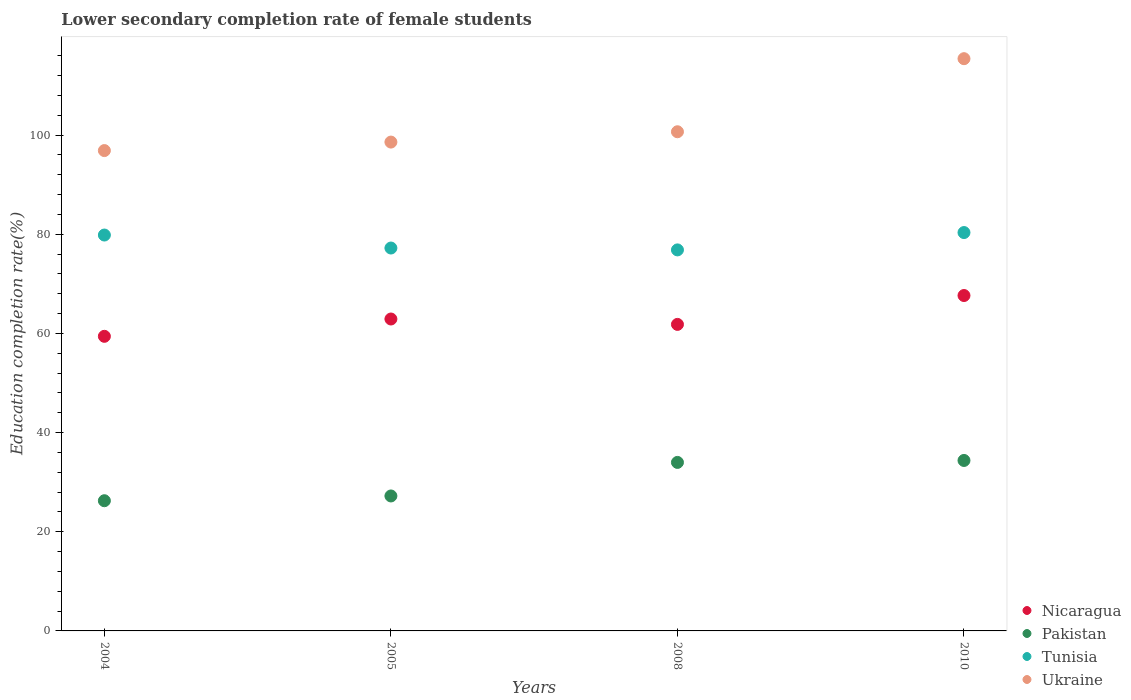How many different coloured dotlines are there?
Make the answer very short. 4. Is the number of dotlines equal to the number of legend labels?
Make the answer very short. Yes. What is the lower secondary completion rate of female students in Nicaragua in 2010?
Your answer should be very brief. 67.65. Across all years, what is the maximum lower secondary completion rate of female students in Pakistan?
Ensure brevity in your answer.  34.38. Across all years, what is the minimum lower secondary completion rate of female students in Pakistan?
Make the answer very short. 26.26. In which year was the lower secondary completion rate of female students in Pakistan maximum?
Provide a short and direct response. 2010. In which year was the lower secondary completion rate of female students in Pakistan minimum?
Make the answer very short. 2004. What is the total lower secondary completion rate of female students in Ukraine in the graph?
Provide a succinct answer. 411.59. What is the difference between the lower secondary completion rate of female students in Tunisia in 2005 and that in 2008?
Offer a very short reply. 0.38. What is the difference between the lower secondary completion rate of female students in Pakistan in 2008 and the lower secondary completion rate of female students in Nicaragua in 2010?
Keep it short and to the point. -33.66. What is the average lower secondary completion rate of female students in Nicaragua per year?
Ensure brevity in your answer.  62.95. In the year 2008, what is the difference between the lower secondary completion rate of female students in Pakistan and lower secondary completion rate of female students in Nicaragua?
Your answer should be very brief. -27.84. In how many years, is the lower secondary completion rate of female students in Pakistan greater than 96 %?
Provide a succinct answer. 0. What is the ratio of the lower secondary completion rate of female students in Ukraine in 2004 to that in 2005?
Your response must be concise. 0.98. Is the lower secondary completion rate of female students in Nicaragua in 2004 less than that in 2005?
Make the answer very short. Yes. Is the difference between the lower secondary completion rate of female students in Pakistan in 2004 and 2008 greater than the difference between the lower secondary completion rate of female students in Nicaragua in 2004 and 2008?
Keep it short and to the point. No. What is the difference between the highest and the second highest lower secondary completion rate of female students in Nicaragua?
Provide a short and direct response. 4.74. What is the difference between the highest and the lowest lower secondary completion rate of female students in Nicaragua?
Keep it short and to the point. 8.23. In how many years, is the lower secondary completion rate of female students in Nicaragua greater than the average lower secondary completion rate of female students in Nicaragua taken over all years?
Your answer should be compact. 1. Does the lower secondary completion rate of female students in Nicaragua monotonically increase over the years?
Keep it short and to the point. No. Is the lower secondary completion rate of female students in Pakistan strictly less than the lower secondary completion rate of female students in Tunisia over the years?
Make the answer very short. Yes. How many dotlines are there?
Give a very brief answer. 4. Are the values on the major ticks of Y-axis written in scientific E-notation?
Provide a short and direct response. No. Does the graph contain grids?
Give a very brief answer. No. How many legend labels are there?
Offer a terse response. 4. What is the title of the graph?
Offer a very short reply. Lower secondary completion rate of female students. Does "Least developed countries" appear as one of the legend labels in the graph?
Give a very brief answer. No. What is the label or title of the X-axis?
Your response must be concise. Years. What is the label or title of the Y-axis?
Provide a succinct answer. Education completion rate(%). What is the Education completion rate(%) of Nicaragua in 2004?
Give a very brief answer. 59.42. What is the Education completion rate(%) in Pakistan in 2004?
Your answer should be compact. 26.26. What is the Education completion rate(%) in Tunisia in 2004?
Offer a terse response. 79.85. What is the Education completion rate(%) in Ukraine in 2004?
Your answer should be compact. 96.89. What is the Education completion rate(%) in Nicaragua in 2005?
Your answer should be very brief. 62.91. What is the Education completion rate(%) in Pakistan in 2005?
Your response must be concise. 27.22. What is the Education completion rate(%) of Tunisia in 2005?
Your response must be concise. 77.23. What is the Education completion rate(%) of Ukraine in 2005?
Keep it short and to the point. 98.6. What is the Education completion rate(%) in Nicaragua in 2008?
Give a very brief answer. 61.83. What is the Education completion rate(%) in Pakistan in 2008?
Keep it short and to the point. 33.99. What is the Education completion rate(%) in Tunisia in 2008?
Your response must be concise. 76.85. What is the Education completion rate(%) of Ukraine in 2008?
Your response must be concise. 100.68. What is the Education completion rate(%) in Nicaragua in 2010?
Provide a short and direct response. 67.65. What is the Education completion rate(%) in Pakistan in 2010?
Offer a very short reply. 34.38. What is the Education completion rate(%) in Tunisia in 2010?
Provide a succinct answer. 80.35. What is the Education completion rate(%) in Ukraine in 2010?
Ensure brevity in your answer.  115.42. Across all years, what is the maximum Education completion rate(%) in Nicaragua?
Provide a short and direct response. 67.65. Across all years, what is the maximum Education completion rate(%) of Pakistan?
Make the answer very short. 34.38. Across all years, what is the maximum Education completion rate(%) of Tunisia?
Make the answer very short. 80.35. Across all years, what is the maximum Education completion rate(%) of Ukraine?
Offer a terse response. 115.42. Across all years, what is the minimum Education completion rate(%) in Nicaragua?
Provide a short and direct response. 59.42. Across all years, what is the minimum Education completion rate(%) in Pakistan?
Offer a very short reply. 26.26. Across all years, what is the minimum Education completion rate(%) in Tunisia?
Provide a short and direct response. 76.85. Across all years, what is the minimum Education completion rate(%) in Ukraine?
Offer a very short reply. 96.89. What is the total Education completion rate(%) of Nicaragua in the graph?
Your answer should be very brief. 251.81. What is the total Education completion rate(%) in Pakistan in the graph?
Give a very brief answer. 121.85. What is the total Education completion rate(%) in Tunisia in the graph?
Give a very brief answer. 314.28. What is the total Education completion rate(%) in Ukraine in the graph?
Offer a terse response. 411.59. What is the difference between the Education completion rate(%) of Nicaragua in 2004 and that in 2005?
Ensure brevity in your answer.  -3.49. What is the difference between the Education completion rate(%) of Pakistan in 2004 and that in 2005?
Your answer should be very brief. -0.96. What is the difference between the Education completion rate(%) in Tunisia in 2004 and that in 2005?
Give a very brief answer. 2.62. What is the difference between the Education completion rate(%) of Ukraine in 2004 and that in 2005?
Your response must be concise. -1.71. What is the difference between the Education completion rate(%) of Nicaragua in 2004 and that in 2008?
Offer a terse response. -2.41. What is the difference between the Education completion rate(%) of Pakistan in 2004 and that in 2008?
Your answer should be compact. -7.73. What is the difference between the Education completion rate(%) of Tunisia in 2004 and that in 2008?
Your response must be concise. 3. What is the difference between the Education completion rate(%) in Ukraine in 2004 and that in 2008?
Your response must be concise. -3.8. What is the difference between the Education completion rate(%) in Nicaragua in 2004 and that in 2010?
Offer a very short reply. -8.23. What is the difference between the Education completion rate(%) of Pakistan in 2004 and that in 2010?
Provide a succinct answer. -8.12. What is the difference between the Education completion rate(%) of Tunisia in 2004 and that in 2010?
Ensure brevity in your answer.  -0.5. What is the difference between the Education completion rate(%) of Ukraine in 2004 and that in 2010?
Your answer should be very brief. -18.54. What is the difference between the Education completion rate(%) in Nicaragua in 2005 and that in 2008?
Provide a short and direct response. 1.09. What is the difference between the Education completion rate(%) in Pakistan in 2005 and that in 2008?
Give a very brief answer. -6.77. What is the difference between the Education completion rate(%) of Tunisia in 2005 and that in 2008?
Your answer should be compact. 0.38. What is the difference between the Education completion rate(%) of Ukraine in 2005 and that in 2008?
Provide a short and direct response. -2.08. What is the difference between the Education completion rate(%) of Nicaragua in 2005 and that in 2010?
Keep it short and to the point. -4.74. What is the difference between the Education completion rate(%) in Pakistan in 2005 and that in 2010?
Make the answer very short. -7.16. What is the difference between the Education completion rate(%) of Tunisia in 2005 and that in 2010?
Provide a short and direct response. -3.12. What is the difference between the Education completion rate(%) of Ukraine in 2005 and that in 2010?
Make the answer very short. -16.82. What is the difference between the Education completion rate(%) in Nicaragua in 2008 and that in 2010?
Provide a succinct answer. -5.82. What is the difference between the Education completion rate(%) of Pakistan in 2008 and that in 2010?
Keep it short and to the point. -0.39. What is the difference between the Education completion rate(%) in Tunisia in 2008 and that in 2010?
Ensure brevity in your answer.  -3.5. What is the difference between the Education completion rate(%) in Ukraine in 2008 and that in 2010?
Provide a short and direct response. -14.74. What is the difference between the Education completion rate(%) of Nicaragua in 2004 and the Education completion rate(%) of Pakistan in 2005?
Provide a short and direct response. 32.2. What is the difference between the Education completion rate(%) of Nicaragua in 2004 and the Education completion rate(%) of Tunisia in 2005?
Ensure brevity in your answer.  -17.81. What is the difference between the Education completion rate(%) in Nicaragua in 2004 and the Education completion rate(%) in Ukraine in 2005?
Offer a very short reply. -39.18. What is the difference between the Education completion rate(%) of Pakistan in 2004 and the Education completion rate(%) of Tunisia in 2005?
Provide a short and direct response. -50.97. What is the difference between the Education completion rate(%) of Pakistan in 2004 and the Education completion rate(%) of Ukraine in 2005?
Offer a terse response. -72.34. What is the difference between the Education completion rate(%) of Tunisia in 2004 and the Education completion rate(%) of Ukraine in 2005?
Offer a terse response. -18.75. What is the difference between the Education completion rate(%) of Nicaragua in 2004 and the Education completion rate(%) of Pakistan in 2008?
Provide a succinct answer. 25.43. What is the difference between the Education completion rate(%) in Nicaragua in 2004 and the Education completion rate(%) in Tunisia in 2008?
Give a very brief answer. -17.43. What is the difference between the Education completion rate(%) in Nicaragua in 2004 and the Education completion rate(%) in Ukraine in 2008?
Provide a short and direct response. -41.26. What is the difference between the Education completion rate(%) in Pakistan in 2004 and the Education completion rate(%) in Tunisia in 2008?
Your answer should be compact. -50.59. What is the difference between the Education completion rate(%) of Pakistan in 2004 and the Education completion rate(%) of Ukraine in 2008?
Offer a terse response. -74.42. What is the difference between the Education completion rate(%) in Tunisia in 2004 and the Education completion rate(%) in Ukraine in 2008?
Ensure brevity in your answer.  -20.83. What is the difference between the Education completion rate(%) of Nicaragua in 2004 and the Education completion rate(%) of Pakistan in 2010?
Keep it short and to the point. 25.04. What is the difference between the Education completion rate(%) in Nicaragua in 2004 and the Education completion rate(%) in Tunisia in 2010?
Provide a short and direct response. -20.93. What is the difference between the Education completion rate(%) in Nicaragua in 2004 and the Education completion rate(%) in Ukraine in 2010?
Your answer should be compact. -56. What is the difference between the Education completion rate(%) in Pakistan in 2004 and the Education completion rate(%) in Tunisia in 2010?
Offer a very short reply. -54.09. What is the difference between the Education completion rate(%) in Pakistan in 2004 and the Education completion rate(%) in Ukraine in 2010?
Provide a short and direct response. -89.16. What is the difference between the Education completion rate(%) of Tunisia in 2004 and the Education completion rate(%) of Ukraine in 2010?
Offer a very short reply. -35.57. What is the difference between the Education completion rate(%) of Nicaragua in 2005 and the Education completion rate(%) of Pakistan in 2008?
Make the answer very short. 28.92. What is the difference between the Education completion rate(%) of Nicaragua in 2005 and the Education completion rate(%) of Tunisia in 2008?
Offer a terse response. -13.94. What is the difference between the Education completion rate(%) in Nicaragua in 2005 and the Education completion rate(%) in Ukraine in 2008?
Provide a short and direct response. -37.77. What is the difference between the Education completion rate(%) in Pakistan in 2005 and the Education completion rate(%) in Tunisia in 2008?
Make the answer very short. -49.63. What is the difference between the Education completion rate(%) in Pakistan in 2005 and the Education completion rate(%) in Ukraine in 2008?
Offer a very short reply. -73.46. What is the difference between the Education completion rate(%) of Tunisia in 2005 and the Education completion rate(%) of Ukraine in 2008?
Keep it short and to the point. -23.45. What is the difference between the Education completion rate(%) in Nicaragua in 2005 and the Education completion rate(%) in Pakistan in 2010?
Offer a very short reply. 28.53. What is the difference between the Education completion rate(%) in Nicaragua in 2005 and the Education completion rate(%) in Tunisia in 2010?
Keep it short and to the point. -17.44. What is the difference between the Education completion rate(%) in Nicaragua in 2005 and the Education completion rate(%) in Ukraine in 2010?
Offer a very short reply. -52.51. What is the difference between the Education completion rate(%) of Pakistan in 2005 and the Education completion rate(%) of Tunisia in 2010?
Provide a short and direct response. -53.13. What is the difference between the Education completion rate(%) in Pakistan in 2005 and the Education completion rate(%) in Ukraine in 2010?
Offer a very short reply. -88.2. What is the difference between the Education completion rate(%) of Tunisia in 2005 and the Education completion rate(%) of Ukraine in 2010?
Keep it short and to the point. -38.19. What is the difference between the Education completion rate(%) in Nicaragua in 2008 and the Education completion rate(%) in Pakistan in 2010?
Make the answer very short. 27.45. What is the difference between the Education completion rate(%) of Nicaragua in 2008 and the Education completion rate(%) of Tunisia in 2010?
Make the answer very short. -18.52. What is the difference between the Education completion rate(%) in Nicaragua in 2008 and the Education completion rate(%) in Ukraine in 2010?
Your answer should be very brief. -53.59. What is the difference between the Education completion rate(%) of Pakistan in 2008 and the Education completion rate(%) of Tunisia in 2010?
Provide a short and direct response. -46.36. What is the difference between the Education completion rate(%) of Pakistan in 2008 and the Education completion rate(%) of Ukraine in 2010?
Give a very brief answer. -81.43. What is the difference between the Education completion rate(%) in Tunisia in 2008 and the Education completion rate(%) in Ukraine in 2010?
Offer a very short reply. -38.57. What is the average Education completion rate(%) in Nicaragua per year?
Provide a succinct answer. 62.95. What is the average Education completion rate(%) in Pakistan per year?
Your response must be concise. 30.46. What is the average Education completion rate(%) in Tunisia per year?
Offer a terse response. 78.57. What is the average Education completion rate(%) in Ukraine per year?
Give a very brief answer. 102.9. In the year 2004, what is the difference between the Education completion rate(%) in Nicaragua and Education completion rate(%) in Pakistan?
Your answer should be very brief. 33.16. In the year 2004, what is the difference between the Education completion rate(%) in Nicaragua and Education completion rate(%) in Tunisia?
Ensure brevity in your answer.  -20.43. In the year 2004, what is the difference between the Education completion rate(%) in Nicaragua and Education completion rate(%) in Ukraine?
Keep it short and to the point. -37.46. In the year 2004, what is the difference between the Education completion rate(%) of Pakistan and Education completion rate(%) of Tunisia?
Offer a terse response. -53.59. In the year 2004, what is the difference between the Education completion rate(%) of Pakistan and Education completion rate(%) of Ukraine?
Provide a succinct answer. -70.63. In the year 2004, what is the difference between the Education completion rate(%) of Tunisia and Education completion rate(%) of Ukraine?
Keep it short and to the point. -17.03. In the year 2005, what is the difference between the Education completion rate(%) of Nicaragua and Education completion rate(%) of Pakistan?
Your answer should be very brief. 35.69. In the year 2005, what is the difference between the Education completion rate(%) of Nicaragua and Education completion rate(%) of Tunisia?
Your answer should be compact. -14.32. In the year 2005, what is the difference between the Education completion rate(%) in Nicaragua and Education completion rate(%) in Ukraine?
Keep it short and to the point. -35.69. In the year 2005, what is the difference between the Education completion rate(%) of Pakistan and Education completion rate(%) of Tunisia?
Your answer should be very brief. -50.01. In the year 2005, what is the difference between the Education completion rate(%) of Pakistan and Education completion rate(%) of Ukraine?
Offer a terse response. -71.38. In the year 2005, what is the difference between the Education completion rate(%) of Tunisia and Education completion rate(%) of Ukraine?
Keep it short and to the point. -21.37. In the year 2008, what is the difference between the Education completion rate(%) of Nicaragua and Education completion rate(%) of Pakistan?
Give a very brief answer. 27.84. In the year 2008, what is the difference between the Education completion rate(%) of Nicaragua and Education completion rate(%) of Tunisia?
Ensure brevity in your answer.  -15.02. In the year 2008, what is the difference between the Education completion rate(%) in Nicaragua and Education completion rate(%) in Ukraine?
Offer a terse response. -38.86. In the year 2008, what is the difference between the Education completion rate(%) of Pakistan and Education completion rate(%) of Tunisia?
Ensure brevity in your answer.  -42.86. In the year 2008, what is the difference between the Education completion rate(%) in Pakistan and Education completion rate(%) in Ukraine?
Make the answer very short. -66.69. In the year 2008, what is the difference between the Education completion rate(%) of Tunisia and Education completion rate(%) of Ukraine?
Keep it short and to the point. -23.83. In the year 2010, what is the difference between the Education completion rate(%) of Nicaragua and Education completion rate(%) of Pakistan?
Provide a short and direct response. 33.27. In the year 2010, what is the difference between the Education completion rate(%) in Nicaragua and Education completion rate(%) in Tunisia?
Provide a short and direct response. -12.7. In the year 2010, what is the difference between the Education completion rate(%) in Nicaragua and Education completion rate(%) in Ukraine?
Ensure brevity in your answer.  -47.77. In the year 2010, what is the difference between the Education completion rate(%) of Pakistan and Education completion rate(%) of Tunisia?
Keep it short and to the point. -45.97. In the year 2010, what is the difference between the Education completion rate(%) in Pakistan and Education completion rate(%) in Ukraine?
Ensure brevity in your answer.  -81.04. In the year 2010, what is the difference between the Education completion rate(%) in Tunisia and Education completion rate(%) in Ukraine?
Make the answer very short. -35.07. What is the ratio of the Education completion rate(%) of Nicaragua in 2004 to that in 2005?
Keep it short and to the point. 0.94. What is the ratio of the Education completion rate(%) in Pakistan in 2004 to that in 2005?
Your answer should be compact. 0.96. What is the ratio of the Education completion rate(%) in Tunisia in 2004 to that in 2005?
Give a very brief answer. 1.03. What is the ratio of the Education completion rate(%) of Ukraine in 2004 to that in 2005?
Make the answer very short. 0.98. What is the ratio of the Education completion rate(%) of Nicaragua in 2004 to that in 2008?
Your answer should be compact. 0.96. What is the ratio of the Education completion rate(%) of Pakistan in 2004 to that in 2008?
Give a very brief answer. 0.77. What is the ratio of the Education completion rate(%) in Tunisia in 2004 to that in 2008?
Provide a short and direct response. 1.04. What is the ratio of the Education completion rate(%) of Ukraine in 2004 to that in 2008?
Your answer should be compact. 0.96. What is the ratio of the Education completion rate(%) of Nicaragua in 2004 to that in 2010?
Your answer should be compact. 0.88. What is the ratio of the Education completion rate(%) in Pakistan in 2004 to that in 2010?
Offer a very short reply. 0.76. What is the ratio of the Education completion rate(%) of Tunisia in 2004 to that in 2010?
Keep it short and to the point. 0.99. What is the ratio of the Education completion rate(%) in Ukraine in 2004 to that in 2010?
Your answer should be compact. 0.84. What is the ratio of the Education completion rate(%) of Nicaragua in 2005 to that in 2008?
Provide a short and direct response. 1.02. What is the ratio of the Education completion rate(%) in Pakistan in 2005 to that in 2008?
Keep it short and to the point. 0.8. What is the ratio of the Education completion rate(%) of Ukraine in 2005 to that in 2008?
Keep it short and to the point. 0.98. What is the ratio of the Education completion rate(%) in Nicaragua in 2005 to that in 2010?
Your response must be concise. 0.93. What is the ratio of the Education completion rate(%) of Pakistan in 2005 to that in 2010?
Your response must be concise. 0.79. What is the ratio of the Education completion rate(%) in Tunisia in 2005 to that in 2010?
Provide a succinct answer. 0.96. What is the ratio of the Education completion rate(%) of Ukraine in 2005 to that in 2010?
Provide a short and direct response. 0.85. What is the ratio of the Education completion rate(%) of Nicaragua in 2008 to that in 2010?
Provide a succinct answer. 0.91. What is the ratio of the Education completion rate(%) in Tunisia in 2008 to that in 2010?
Ensure brevity in your answer.  0.96. What is the ratio of the Education completion rate(%) in Ukraine in 2008 to that in 2010?
Your response must be concise. 0.87. What is the difference between the highest and the second highest Education completion rate(%) in Nicaragua?
Make the answer very short. 4.74. What is the difference between the highest and the second highest Education completion rate(%) of Pakistan?
Provide a short and direct response. 0.39. What is the difference between the highest and the second highest Education completion rate(%) in Tunisia?
Make the answer very short. 0.5. What is the difference between the highest and the second highest Education completion rate(%) of Ukraine?
Your answer should be compact. 14.74. What is the difference between the highest and the lowest Education completion rate(%) of Nicaragua?
Provide a succinct answer. 8.23. What is the difference between the highest and the lowest Education completion rate(%) in Pakistan?
Keep it short and to the point. 8.12. What is the difference between the highest and the lowest Education completion rate(%) in Tunisia?
Your response must be concise. 3.5. What is the difference between the highest and the lowest Education completion rate(%) in Ukraine?
Your response must be concise. 18.54. 